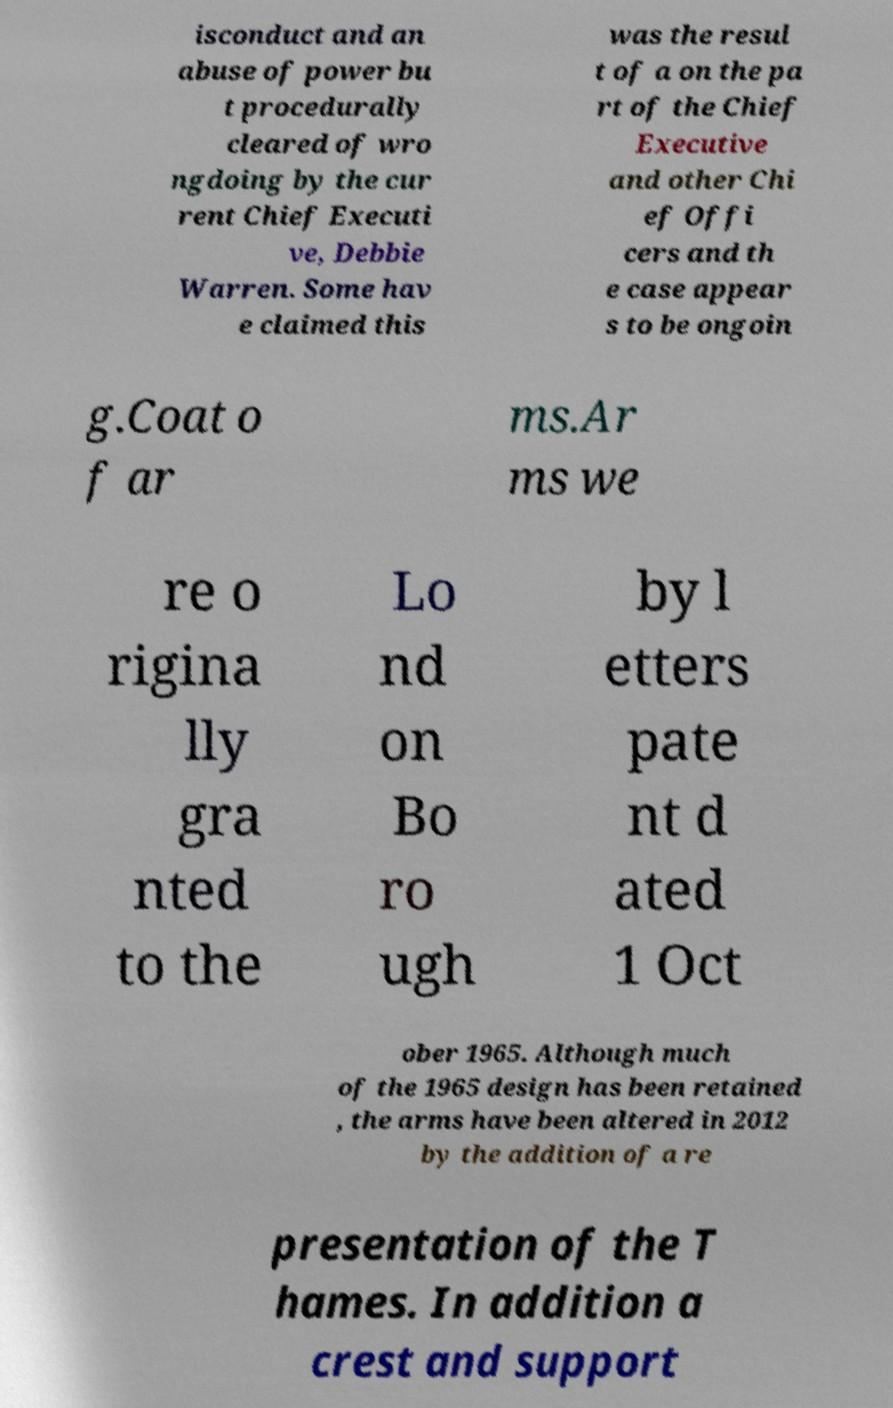Please identify and transcribe the text found in this image. isconduct and an abuse of power bu t procedurally cleared of wro ngdoing by the cur rent Chief Executi ve, Debbie Warren. Some hav e claimed this was the resul t of a on the pa rt of the Chief Executive and other Chi ef Offi cers and th e case appear s to be ongoin g.Coat o f ar ms.Ar ms we re o rigina lly gra nted to the Lo nd on Bo ro ugh by l etters pate nt d ated 1 Oct ober 1965. Although much of the 1965 design has been retained , the arms have been altered in 2012 by the addition of a re presentation of the T hames. In addition a crest and support 